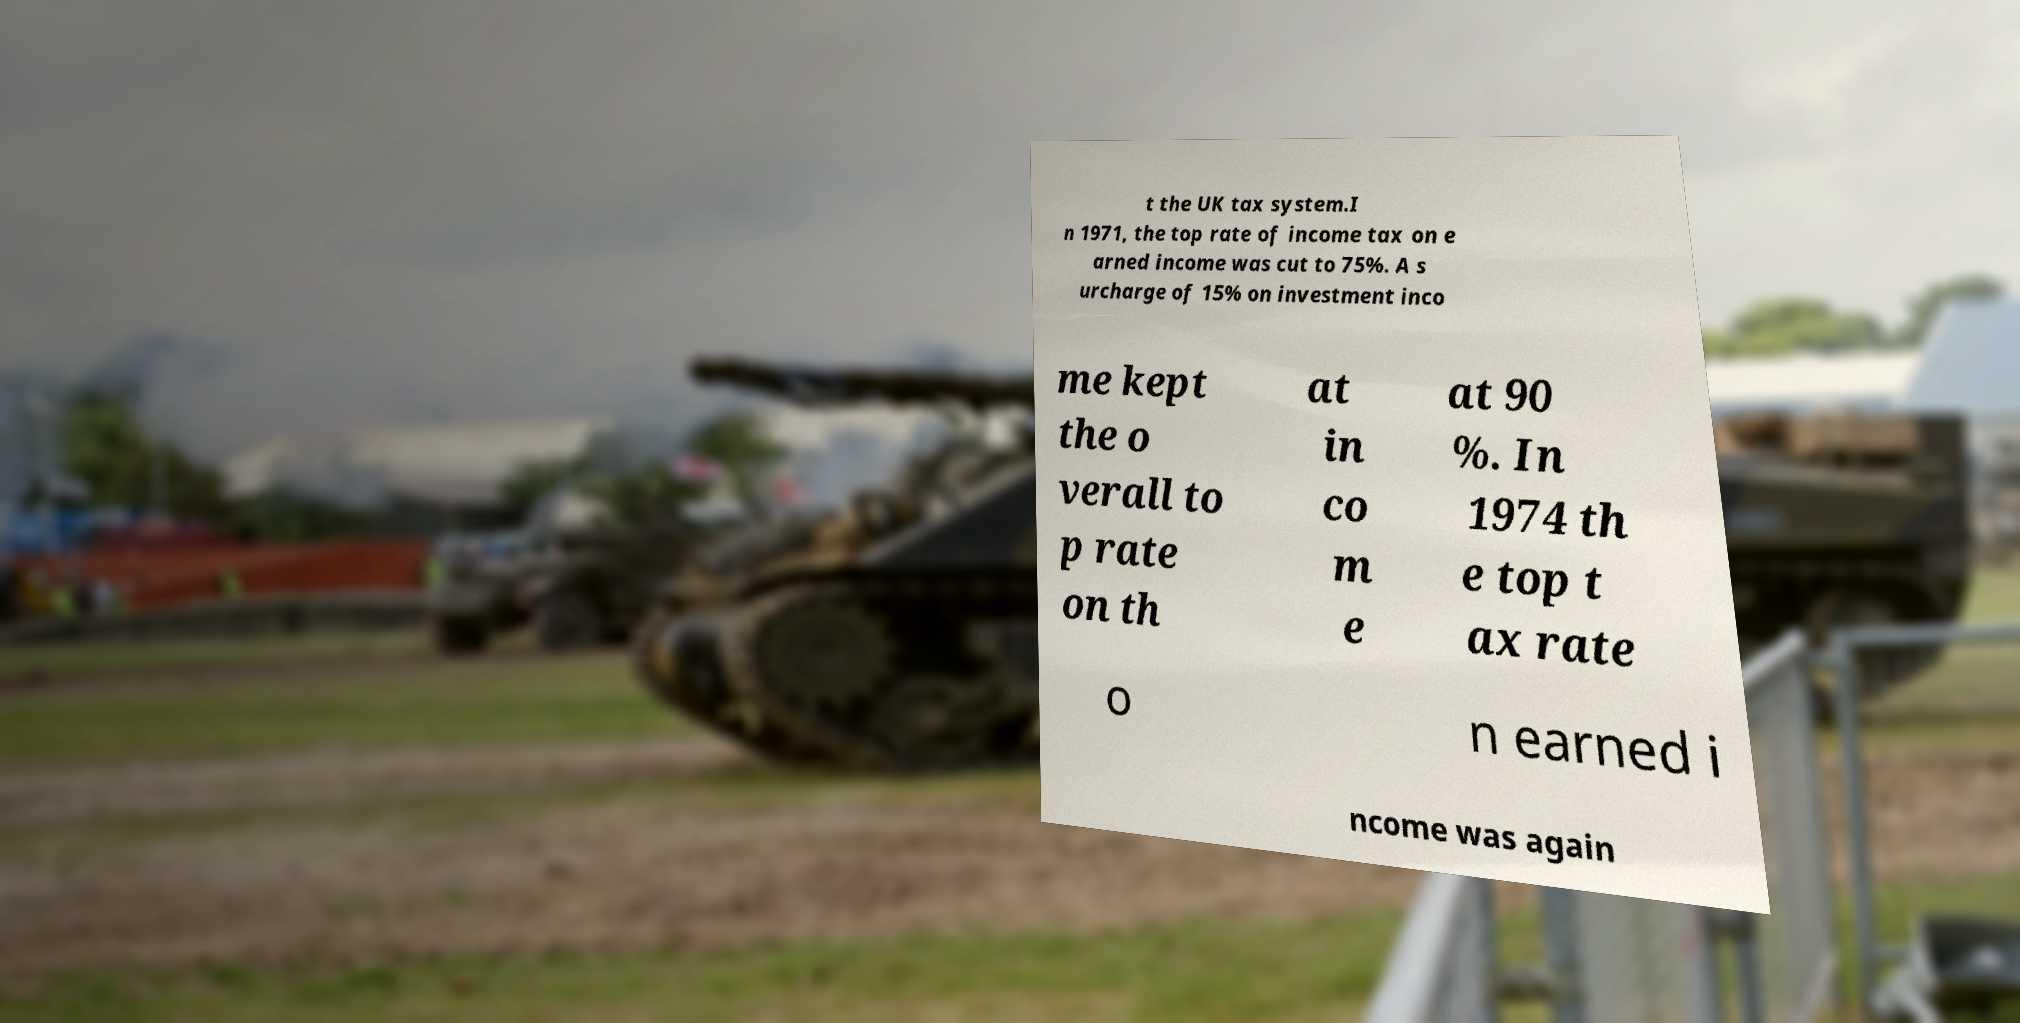Can you read and provide the text displayed in the image?This photo seems to have some interesting text. Can you extract and type it out for me? t the UK tax system.I n 1971, the top rate of income tax on e arned income was cut to 75%. A s urcharge of 15% on investment inco me kept the o verall to p rate on th at in co m e at 90 %. In 1974 th e top t ax rate o n earned i ncome was again 